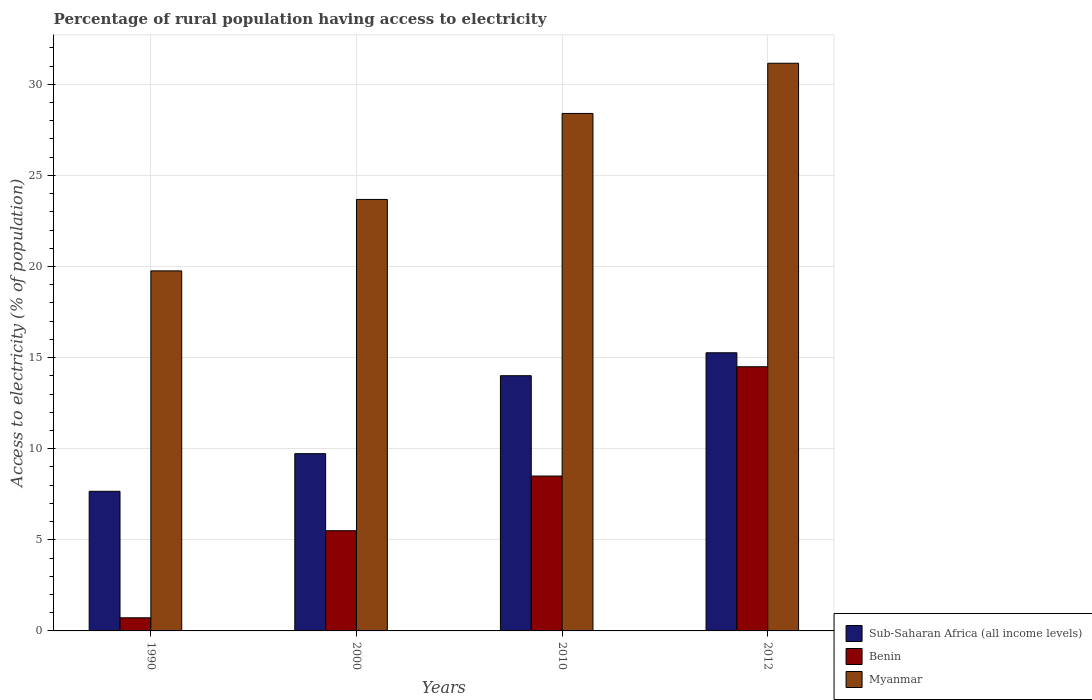How many bars are there on the 4th tick from the left?
Offer a very short reply. 3. How many bars are there on the 1st tick from the right?
Provide a succinct answer. 3. What is the label of the 3rd group of bars from the left?
Provide a short and direct response. 2010. In how many cases, is the number of bars for a given year not equal to the number of legend labels?
Your answer should be very brief. 0. Across all years, what is the maximum percentage of rural population having access to electricity in Myanmar?
Your answer should be very brief. 31.15. Across all years, what is the minimum percentage of rural population having access to electricity in Benin?
Ensure brevity in your answer.  0.72. In which year was the percentage of rural population having access to electricity in Myanmar minimum?
Your response must be concise. 1990. What is the total percentage of rural population having access to electricity in Myanmar in the graph?
Your answer should be very brief. 103. What is the difference between the percentage of rural population having access to electricity in Sub-Saharan Africa (all income levels) in 2010 and that in 2012?
Keep it short and to the point. -1.26. What is the difference between the percentage of rural population having access to electricity in Benin in 2010 and the percentage of rural population having access to electricity in Myanmar in 1990?
Ensure brevity in your answer.  -11.26. What is the average percentage of rural population having access to electricity in Sub-Saharan Africa (all income levels) per year?
Provide a short and direct response. 11.67. In the year 2000, what is the difference between the percentage of rural population having access to electricity in Sub-Saharan Africa (all income levels) and percentage of rural population having access to electricity in Benin?
Your answer should be very brief. 4.23. In how many years, is the percentage of rural population having access to electricity in Sub-Saharan Africa (all income levels) greater than 13 %?
Give a very brief answer. 2. What is the ratio of the percentage of rural population having access to electricity in Benin in 2000 to that in 2012?
Give a very brief answer. 0.38. Is the percentage of rural population having access to electricity in Myanmar in 2000 less than that in 2012?
Provide a succinct answer. Yes. Is the difference between the percentage of rural population having access to electricity in Sub-Saharan Africa (all income levels) in 1990 and 2012 greater than the difference between the percentage of rural population having access to electricity in Benin in 1990 and 2012?
Your response must be concise. Yes. What is the difference between the highest and the second highest percentage of rural population having access to electricity in Sub-Saharan Africa (all income levels)?
Provide a succinct answer. 1.26. What is the difference between the highest and the lowest percentage of rural population having access to electricity in Myanmar?
Provide a short and direct response. 11.39. In how many years, is the percentage of rural population having access to electricity in Myanmar greater than the average percentage of rural population having access to electricity in Myanmar taken over all years?
Make the answer very short. 2. Is the sum of the percentage of rural population having access to electricity in Benin in 2000 and 2012 greater than the maximum percentage of rural population having access to electricity in Myanmar across all years?
Your answer should be compact. No. What does the 2nd bar from the left in 1990 represents?
Your answer should be compact. Benin. What does the 3rd bar from the right in 2000 represents?
Keep it short and to the point. Sub-Saharan Africa (all income levels). Is it the case that in every year, the sum of the percentage of rural population having access to electricity in Benin and percentage of rural population having access to electricity in Myanmar is greater than the percentage of rural population having access to electricity in Sub-Saharan Africa (all income levels)?
Make the answer very short. Yes. How many bars are there?
Make the answer very short. 12. Are all the bars in the graph horizontal?
Keep it short and to the point. No. Does the graph contain any zero values?
Your answer should be compact. No. How many legend labels are there?
Offer a terse response. 3. What is the title of the graph?
Keep it short and to the point. Percentage of rural population having access to electricity. Does "High income: nonOECD" appear as one of the legend labels in the graph?
Offer a terse response. No. What is the label or title of the Y-axis?
Your response must be concise. Access to electricity (% of population). What is the Access to electricity (% of population) of Sub-Saharan Africa (all income levels) in 1990?
Give a very brief answer. 7.66. What is the Access to electricity (% of population) of Benin in 1990?
Offer a terse response. 0.72. What is the Access to electricity (% of population) in Myanmar in 1990?
Your answer should be very brief. 19.76. What is the Access to electricity (% of population) in Sub-Saharan Africa (all income levels) in 2000?
Ensure brevity in your answer.  9.73. What is the Access to electricity (% of population) of Benin in 2000?
Your answer should be compact. 5.5. What is the Access to electricity (% of population) in Myanmar in 2000?
Provide a succinct answer. 23.68. What is the Access to electricity (% of population) of Sub-Saharan Africa (all income levels) in 2010?
Provide a succinct answer. 14.01. What is the Access to electricity (% of population) of Benin in 2010?
Your answer should be very brief. 8.5. What is the Access to electricity (% of population) in Myanmar in 2010?
Offer a terse response. 28.4. What is the Access to electricity (% of population) of Sub-Saharan Africa (all income levels) in 2012?
Offer a terse response. 15.27. What is the Access to electricity (% of population) in Myanmar in 2012?
Make the answer very short. 31.15. Across all years, what is the maximum Access to electricity (% of population) of Sub-Saharan Africa (all income levels)?
Make the answer very short. 15.27. Across all years, what is the maximum Access to electricity (% of population) in Benin?
Provide a succinct answer. 14.5. Across all years, what is the maximum Access to electricity (% of population) in Myanmar?
Your answer should be very brief. 31.15. Across all years, what is the minimum Access to electricity (% of population) in Sub-Saharan Africa (all income levels)?
Provide a short and direct response. 7.66. Across all years, what is the minimum Access to electricity (% of population) in Benin?
Offer a very short reply. 0.72. Across all years, what is the minimum Access to electricity (% of population) of Myanmar?
Provide a succinct answer. 19.76. What is the total Access to electricity (% of population) of Sub-Saharan Africa (all income levels) in the graph?
Your response must be concise. 46.66. What is the total Access to electricity (% of population) of Benin in the graph?
Provide a succinct answer. 29.22. What is the total Access to electricity (% of population) in Myanmar in the graph?
Provide a succinct answer. 103. What is the difference between the Access to electricity (% of population) in Sub-Saharan Africa (all income levels) in 1990 and that in 2000?
Ensure brevity in your answer.  -2.07. What is the difference between the Access to electricity (% of population) of Benin in 1990 and that in 2000?
Your response must be concise. -4.78. What is the difference between the Access to electricity (% of population) in Myanmar in 1990 and that in 2000?
Your answer should be compact. -3.92. What is the difference between the Access to electricity (% of population) of Sub-Saharan Africa (all income levels) in 1990 and that in 2010?
Provide a short and direct response. -6.35. What is the difference between the Access to electricity (% of population) of Benin in 1990 and that in 2010?
Give a very brief answer. -7.78. What is the difference between the Access to electricity (% of population) in Myanmar in 1990 and that in 2010?
Give a very brief answer. -8.64. What is the difference between the Access to electricity (% of population) in Sub-Saharan Africa (all income levels) in 1990 and that in 2012?
Provide a succinct answer. -7.6. What is the difference between the Access to electricity (% of population) of Benin in 1990 and that in 2012?
Your response must be concise. -13.78. What is the difference between the Access to electricity (% of population) of Myanmar in 1990 and that in 2012?
Ensure brevity in your answer.  -11.39. What is the difference between the Access to electricity (% of population) of Sub-Saharan Africa (all income levels) in 2000 and that in 2010?
Provide a short and direct response. -4.28. What is the difference between the Access to electricity (% of population) in Benin in 2000 and that in 2010?
Your answer should be compact. -3. What is the difference between the Access to electricity (% of population) in Myanmar in 2000 and that in 2010?
Your answer should be very brief. -4.72. What is the difference between the Access to electricity (% of population) in Sub-Saharan Africa (all income levels) in 2000 and that in 2012?
Ensure brevity in your answer.  -5.54. What is the difference between the Access to electricity (% of population) of Myanmar in 2000 and that in 2012?
Keep it short and to the point. -7.47. What is the difference between the Access to electricity (% of population) of Sub-Saharan Africa (all income levels) in 2010 and that in 2012?
Your response must be concise. -1.26. What is the difference between the Access to electricity (% of population) of Benin in 2010 and that in 2012?
Give a very brief answer. -6. What is the difference between the Access to electricity (% of population) in Myanmar in 2010 and that in 2012?
Ensure brevity in your answer.  -2.75. What is the difference between the Access to electricity (% of population) of Sub-Saharan Africa (all income levels) in 1990 and the Access to electricity (% of population) of Benin in 2000?
Ensure brevity in your answer.  2.16. What is the difference between the Access to electricity (% of population) of Sub-Saharan Africa (all income levels) in 1990 and the Access to electricity (% of population) of Myanmar in 2000?
Offer a terse response. -16.02. What is the difference between the Access to electricity (% of population) of Benin in 1990 and the Access to electricity (% of population) of Myanmar in 2000?
Keep it short and to the point. -22.96. What is the difference between the Access to electricity (% of population) in Sub-Saharan Africa (all income levels) in 1990 and the Access to electricity (% of population) in Benin in 2010?
Offer a very short reply. -0.84. What is the difference between the Access to electricity (% of population) of Sub-Saharan Africa (all income levels) in 1990 and the Access to electricity (% of population) of Myanmar in 2010?
Keep it short and to the point. -20.74. What is the difference between the Access to electricity (% of population) in Benin in 1990 and the Access to electricity (% of population) in Myanmar in 2010?
Make the answer very short. -27.68. What is the difference between the Access to electricity (% of population) in Sub-Saharan Africa (all income levels) in 1990 and the Access to electricity (% of population) in Benin in 2012?
Your response must be concise. -6.84. What is the difference between the Access to electricity (% of population) of Sub-Saharan Africa (all income levels) in 1990 and the Access to electricity (% of population) of Myanmar in 2012?
Ensure brevity in your answer.  -23.49. What is the difference between the Access to electricity (% of population) of Benin in 1990 and the Access to electricity (% of population) of Myanmar in 2012?
Your response must be concise. -30.43. What is the difference between the Access to electricity (% of population) of Sub-Saharan Africa (all income levels) in 2000 and the Access to electricity (% of population) of Benin in 2010?
Keep it short and to the point. 1.23. What is the difference between the Access to electricity (% of population) in Sub-Saharan Africa (all income levels) in 2000 and the Access to electricity (% of population) in Myanmar in 2010?
Offer a terse response. -18.67. What is the difference between the Access to electricity (% of population) of Benin in 2000 and the Access to electricity (% of population) of Myanmar in 2010?
Give a very brief answer. -22.9. What is the difference between the Access to electricity (% of population) of Sub-Saharan Africa (all income levels) in 2000 and the Access to electricity (% of population) of Benin in 2012?
Offer a very short reply. -4.77. What is the difference between the Access to electricity (% of population) of Sub-Saharan Africa (all income levels) in 2000 and the Access to electricity (% of population) of Myanmar in 2012?
Ensure brevity in your answer.  -21.43. What is the difference between the Access to electricity (% of population) in Benin in 2000 and the Access to electricity (% of population) in Myanmar in 2012?
Provide a short and direct response. -25.65. What is the difference between the Access to electricity (% of population) of Sub-Saharan Africa (all income levels) in 2010 and the Access to electricity (% of population) of Benin in 2012?
Offer a very short reply. -0.49. What is the difference between the Access to electricity (% of population) of Sub-Saharan Africa (all income levels) in 2010 and the Access to electricity (% of population) of Myanmar in 2012?
Give a very brief answer. -17.15. What is the difference between the Access to electricity (% of population) of Benin in 2010 and the Access to electricity (% of population) of Myanmar in 2012?
Offer a terse response. -22.65. What is the average Access to electricity (% of population) of Sub-Saharan Africa (all income levels) per year?
Ensure brevity in your answer.  11.67. What is the average Access to electricity (% of population) of Benin per year?
Ensure brevity in your answer.  7.3. What is the average Access to electricity (% of population) in Myanmar per year?
Your answer should be compact. 25.75. In the year 1990, what is the difference between the Access to electricity (% of population) of Sub-Saharan Africa (all income levels) and Access to electricity (% of population) of Benin?
Give a very brief answer. 6.94. In the year 1990, what is the difference between the Access to electricity (% of population) in Sub-Saharan Africa (all income levels) and Access to electricity (% of population) in Myanmar?
Make the answer very short. -12.1. In the year 1990, what is the difference between the Access to electricity (% of population) in Benin and Access to electricity (% of population) in Myanmar?
Give a very brief answer. -19.04. In the year 2000, what is the difference between the Access to electricity (% of population) in Sub-Saharan Africa (all income levels) and Access to electricity (% of population) in Benin?
Provide a succinct answer. 4.23. In the year 2000, what is the difference between the Access to electricity (% of population) in Sub-Saharan Africa (all income levels) and Access to electricity (% of population) in Myanmar?
Give a very brief answer. -13.95. In the year 2000, what is the difference between the Access to electricity (% of population) of Benin and Access to electricity (% of population) of Myanmar?
Offer a terse response. -18.18. In the year 2010, what is the difference between the Access to electricity (% of population) of Sub-Saharan Africa (all income levels) and Access to electricity (% of population) of Benin?
Your answer should be very brief. 5.51. In the year 2010, what is the difference between the Access to electricity (% of population) in Sub-Saharan Africa (all income levels) and Access to electricity (% of population) in Myanmar?
Make the answer very short. -14.39. In the year 2010, what is the difference between the Access to electricity (% of population) of Benin and Access to electricity (% of population) of Myanmar?
Ensure brevity in your answer.  -19.9. In the year 2012, what is the difference between the Access to electricity (% of population) in Sub-Saharan Africa (all income levels) and Access to electricity (% of population) in Benin?
Make the answer very short. 0.77. In the year 2012, what is the difference between the Access to electricity (% of population) of Sub-Saharan Africa (all income levels) and Access to electricity (% of population) of Myanmar?
Make the answer very short. -15.89. In the year 2012, what is the difference between the Access to electricity (% of population) in Benin and Access to electricity (% of population) in Myanmar?
Your answer should be compact. -16.65. What is the ratio of the Access to electricity (% of population) in Sub-Saharan Africa (all income levels) in 1990 to that in 2000?
Provide a succinct answer. 0.79. What is the ratio of the Access to electricity (% of population) of Benin in 1990 to that in 2000?
Provide a succinct answer. 0.13. What is the ratio of the Access to electricity (% of population) in Myanmar in 1990 to that in 2000?
Your response must be concise. 0.83. What is the ratio of the Access to electricity (% of population) in Sub-Saharan Africa (all income levels) in 1990 to that in 2010?
Make the answer very short. 0.55. What is the ratio of the Access to electricity (% of population) in Benin in 1990 to that in 2010?
Your response must be concise. 0.08. What is the ratio of the Access to electricity (% of population) of Myanmar in 1990 to that in 2010?
Make the answer very short. 0.7. What is the ratio of the Access to electricity (% of population) of Sub-Saharan Africa (all income levels) in 1990 to that in 2012?
Provide a short and direct response. 0.5. What is the ratio of the Access to electricity (% of population) in Benin in 1990 to that in 2012?
Make the answer very short. 0.05. What is the ratio of the Access to electricity (% of population) of Myanmar in 1990 to that in 2012?
Ensure brevity in your answer.  0.63. What is the ratio of the Access to electricity (% of population) in Sub-Saharan Africa (all income levels) in 2000 to that in 2010?
Your answer should be compact. 0.69. What is the ratio of the Access to electricity (% of population) of Benin in 2000 to that in 2010?
Offer a very short reply. 0.65. What is the ratio of the Access to electricity (% of population) of Myanmar in 2000 to that in 2010?
Ensure brevity in your answer.  0.83. What is the ratio of the Access to electricity (% of population) of Sub-Saharan Africa (all income levels) in 2000 to that in 2012?
Offer a terse response. 0.64. What is the ratio of the Access to electricity (% of population) of Benin in 2000 to that in 2012?
Your answer should be very brief. 0.38. What is the ratio of the Access to electricity (% of population) of Myanmar in 2000 to that in 2012?
Your answer should be compact. 0.76. What is the ratio of the Access to electricity (% of population) in Sub-Saharan Africa (all income levels) in 2010 to that in 2012?
Ensure brevity in your answer.  0.92. What is the ratio of the Access to electricity (% of population) in Benin in 2010 to that in 2012?
Ensure brevity in your answer.  0.59. What is the ratio of the Access to electricity (% of population) in Myanmar in 2010 to that in 2012?
Make the answer very short. 0.91. What is the difference between the highest and the second highest Access to electricity (% of population) of Sub-Saharan Africa (all income levels)?
Your answer should be compact. 1.26. What is the difference between the highest and the second highest Access to electricity (% of population) in Benin?
Make the answer very short. 6. What is the difference between the highest and the second highest Access to electricity (% of population) of Myanmar?
Offer a terse response. 2.75. What is the difference between the highest and the lowest Access to electricity (% of population) of Sub-Saharan Africa (all income levels)?
Offer a terse response. 7.6. What is the difference between the highest and the lowest Access to electricity (% of population) of Benin?
Provide a short and direct response. 13.78. What is the difference between the highest and the lowest Access to electricity (% of population) of Myanmar?
Offer a terse response. 11.39. 